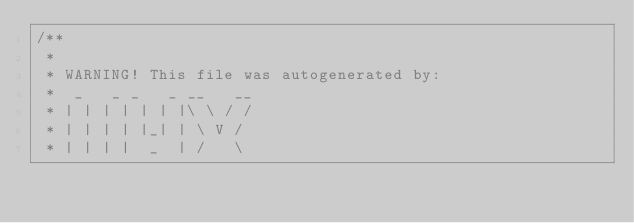Convert code to text. <code><loc_0><loc_0><loc_500><loc_500><_Haxe_>/**
 * 
 * WARNING! This file was autogenerated by: 
 *  _   _ _   _ __   __ 
 * | | | | | | |\ \ / / 
 * | | | | |_| | \ V /  
 * | | | |  _  | /   \  </code> 